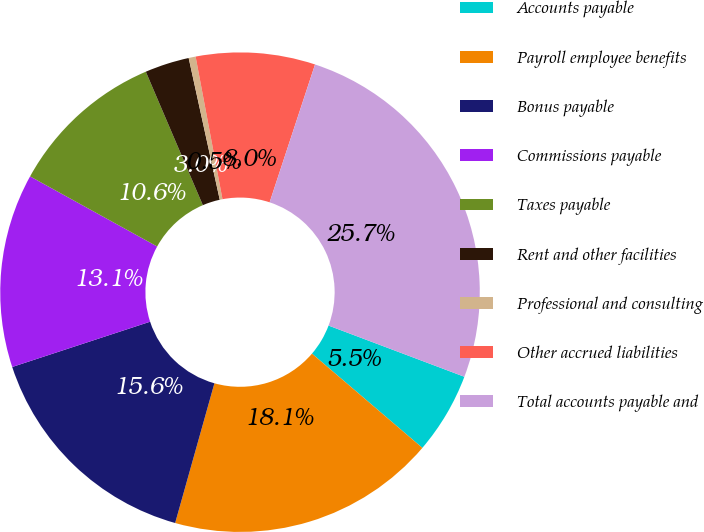<chart> <loc_0><loc_0><loc_500><loc_500><pie_chart><fcel>Accounts payable<fcel>Payroll employee benefits<fcel>Bonus payable<fcel>Commissions payable<fcel>Taxes payable<fcel>Rent and other facilities<fcel>Professional and consulting<fcel>Other accrued liabilities<fcel>Total accounts payable and<nl><fcel>5.51%<fcel>18.11%<fcel>15.59%<fcel>13.07%<fcel>10.55%<fcel>2.99%<fcel>0.47%<fcel>8.03%<fcel>25.67%<nl></chart> 